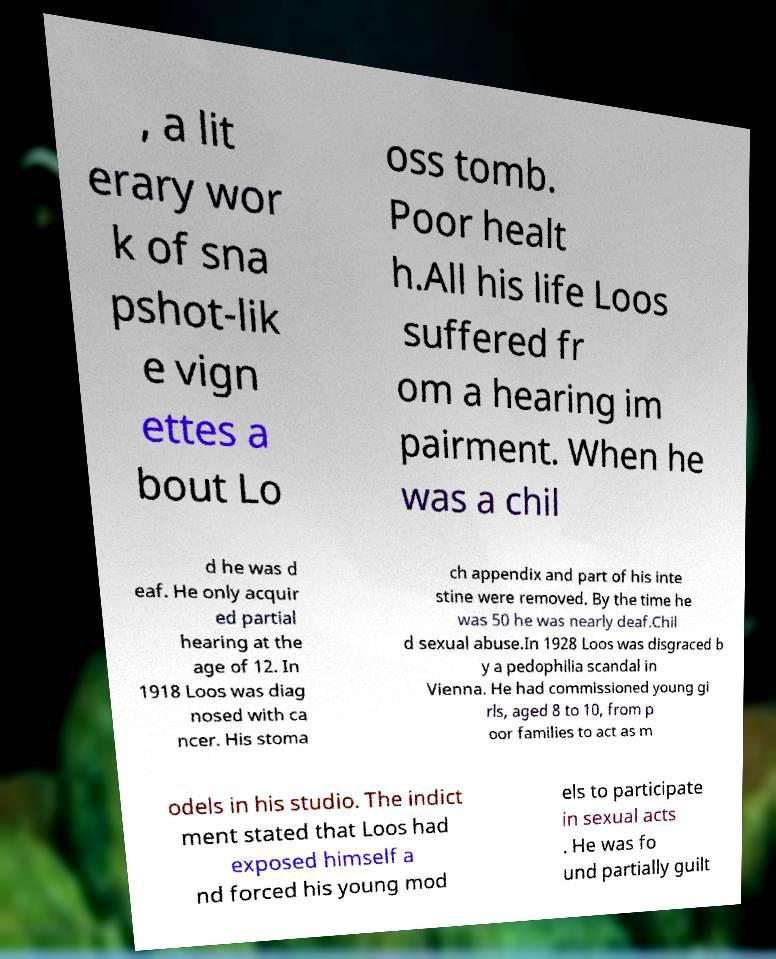Please identify and transcribe the text found in this image. , a lit erary wor k of sna pshot-lik e vign ettes a bout Lo oss tomb. Poor healt h.All his life Loos suffered fr om a hearing im pairment. When he was a chil d he was d eaf. He only acquir ed partial hearing at the age of 12. In 1918 Loos was diag nosed with ca ncer. His stoma ch appendix and part of his inte stine were removed. By the time he was 50 he was nearly deaf.Chil d sexual abuse.In 1928 Loos was disgraced b y a pedophilia scandal in Vienna. He had commissioned young gi rls, aged 8 to 10, from p oor families to act as m odels in his studio. The indict ment stated that Loos had exposed himself a nd forced his young mod els to participate in sexual acts . He was fo und partially guilt 